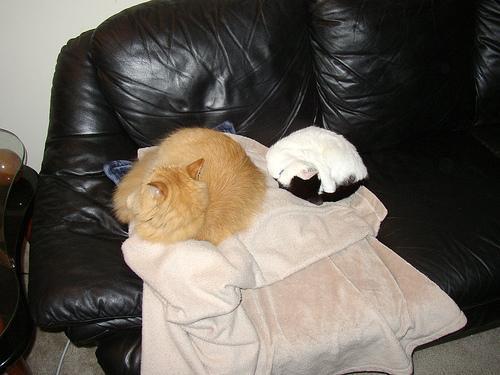How many cats are there?
Give a very brief answer. 2. 